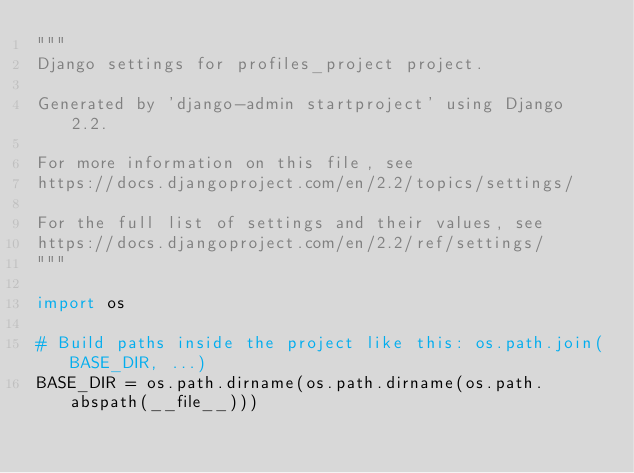Convert code to text. <code><loc_0><loc_0><loc_500><loc_500><_Python_>"""
Django settings for profiles_project project.

Generated by 'django-admin startproject' using Django 2.2.

For more information on this file, see
https://docs.djangoproject.com/en/2.2/topics/settings/

For the full list of settings and their values, see
https://docs.djangoproject.com/en/2.2/ref/settings/
"""

import os

# Build paths inside the project like this: os.path.join(BASE_DIR, ...)
BASE_DIR = os.path.dirname(os.path.dirname(os.path.abspath(__file__)))

</code> 